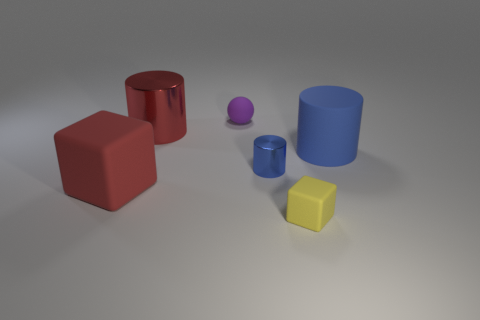Add 1 small blue objects. How many objects exist? 7 Subtract all blocks. How many objects are left? 4 Add 5 big cyan cubes. How many big cyan cubes exist? 5 Subtract 0 brown blocks. How many objects are left? 6 Subtract all blue shiny cylinders. Subtract all big red spheres. How many objects are left? 5 Add 2 blue matte cylinders. How many blue matte cylinders are left? 3 